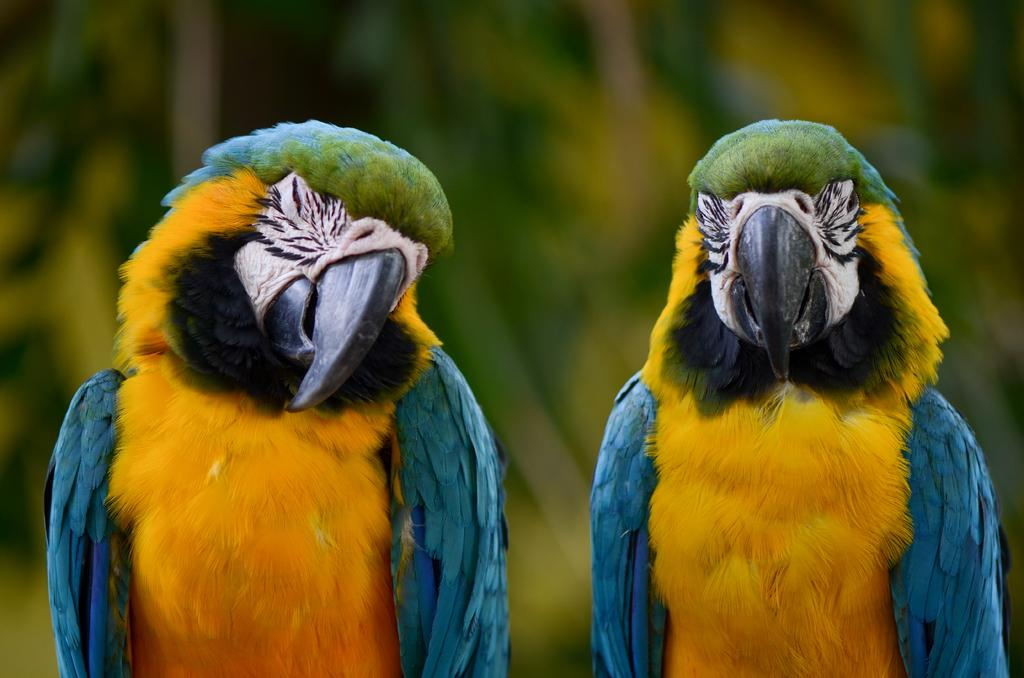How many parrots are in the image? There are two parrots in the image. What colors are the parrots? One parrot is yellow in color, and the other parrot is blue in color. What type of shoes are the parrots wearing in the image? The parrots are birds and do not wear shoes; they have feet with claws. 